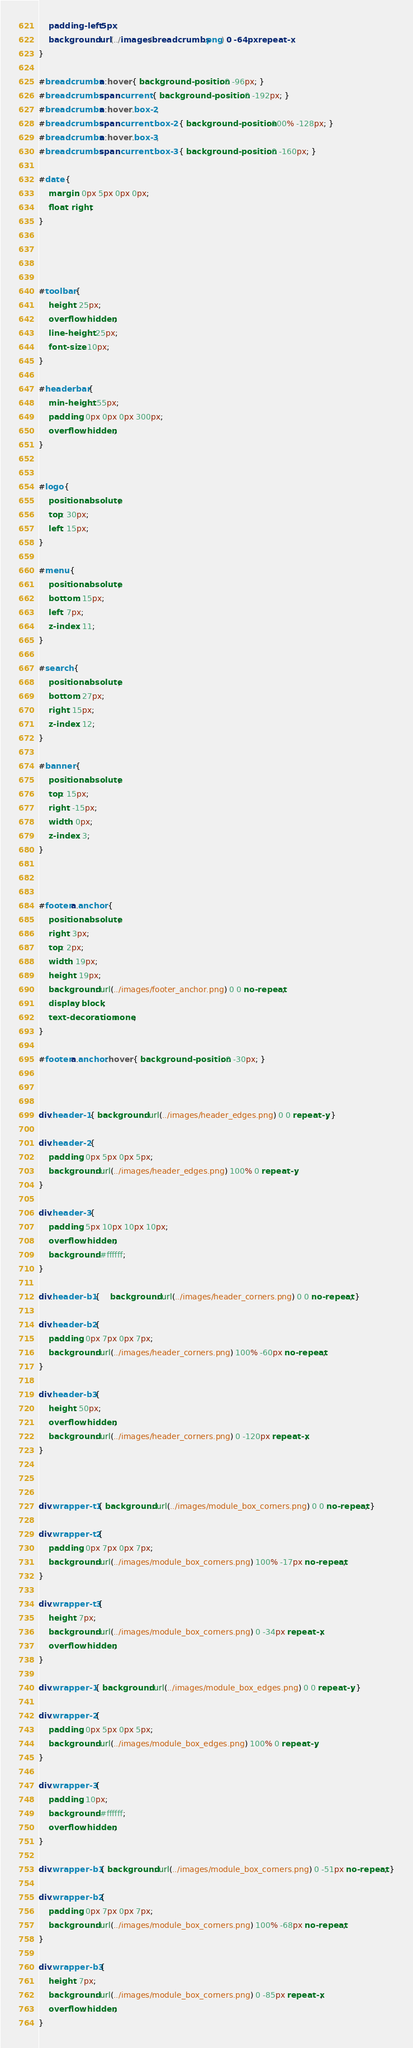Convert code to text. <code><loc_0><loc_0><loc_500><loc_500><_CSS_>	padding-left: 5px;
	background: url(../images/breadcrumbs.png) 0 -64px repeat-x;
}

#breadcrumbs a:hover { background-position: 0 -96px; }
#breadcrumbs span.current { background-position: 0 -192px; }
#breadcrumbs a:hover .box-2,
#breadcrumbs span.current .box-2 { background-position: 100% -128px; }
#breadcrumbs a:hover .box-3,
#breadcrumbs span.current .box-3 { background-position: 0 -160px; }

#date {
	margin: 0px 5px 0px 0px;
	float: right;
}

 

 
#toolbar {
	height: 25px;
	overflow: hidden;
	line-height: 25px;
	font-size: 10px;
}

#headerbar {
	min-height: 55px;
	padding: 0px 0px 0px 300px;
	overflow: hidden;
}

 
#logo {
	position: absolute;
	top: 30px;
	left: 15px;
}

#menu {
	position: absolute;
	bottom: 15px;
	left: 7px;
	z-index: 11;
}

#search {
	position: absolute;
	bottom: 27px;
	right: 15px;
	z-index: 12;
}

#banner {
	position: absolute;
	top: 15px;
	right: -15px;
	width: 0px;
	z-index: 3;
}

 

#footer a.anchor {
	position: absolute;
	right: 3px;
	top: 2px;
	width: 19px;
	height: 19px;
	background: url(../images/footer_anchor.png) 0 0 no-repeat;
	display: block;
	text-decoration: none;
}

#footer a.anchor:hover { background-position: 0 -30px; }

 
 
div.header-1 { background: url(../images/header_edges.png) 0 0 repeat-y; }

div.header-2 {
	padding: 0px 5px 0px 5px;
	background: url(../images/header_edges.png) 100% 0 repeat-y;
}

div.header-3 {
	padding: 5px 10px 10px 10px;
	overflow: hidden;
	background: #ffffff;
}

div.header-b1 {	background: url(../images/header_corners.png) 0 0 no-repeat; }

div.header-b2 {
	padding: 0px 7px 0px 7px;
	background: url(../images/header_corners.png) 100% -60px no-repeat;
}

div.header-b3 {
	height: 50px;
	overflow: hidden;		
	background: url(../images/header_corners.png) 0 -120px repeat-x;
}

 

div.wrapper-t1 { background: url(../images/module_box_corners.png) 0 0 no-repeat; }

div.wrapper-t2 {
	padding: 0px 7px 0px 7px;
	background: url(../images/module_box_corners.png) 100% -17px no-repeat;
}

div.wrapper-t3 {
	height: 7px;
	background: url(../images/module_box_corners.png) 0 -34px repeat-x;
	overflow: hidden;
}

div.wrapper-1 { background: url(../images/module_box_edges.png) 0 0 repeat-y; }

div.wrapper-2 { 
	padding: 0px 5px 0px 5px;
	background: url(../images/module_box_edges.png) 100% 0 repeat-y;
}

div.wrapper-3 { 
	padding: 10px;
	background: #ffffff;
	overflow: hidden;
}

div.wrapper-b1 { background: url(../images/module_box_corners.png) 0 -51px no-repeat; }

div.wrapper-b2 {
	padding: 0px 7px 0px 7px;
	background: url(../images/module_box_corners.png) 100% -68px no-repeat;
}

div.wrapper-b3 {
	height: 7px;
	background: url(../images/module_box_corners.png) 0 -85px repeat-x;
	overflow: hidden;
}</code> 